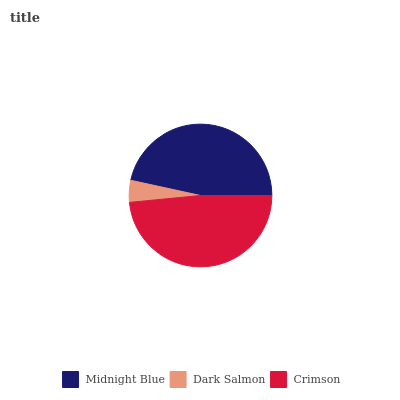Is Dark Salmon the minimum?
Answer yes or no. Yes. Is Crimson the maximum?
Answer yes or no. Yes. Is Crimson the minimum?
Answer yes or no. No. Is Dark Salmon the maximum?
Answer yes or no. No. Is Crimson greater than Dark Salmon?
Answer yes or no. Yes. Is Dark Salmon less than Crimson?
Answer yes or no. Yes. Is Dark Salmon greater than Crimson?
Answer yes or no. No. Is Crimson less than Dark Salmon?
Answer yes or no. No. Is Midnight Blue the high median?
Answer yes or no. Yes. Is Midnight Blue the low median?
Answer yes or no. Yes. Is Dark Salmon the high median?
Answer yes or no. No. Is Dark Salmon the low median?
Answer yes or no. No. 